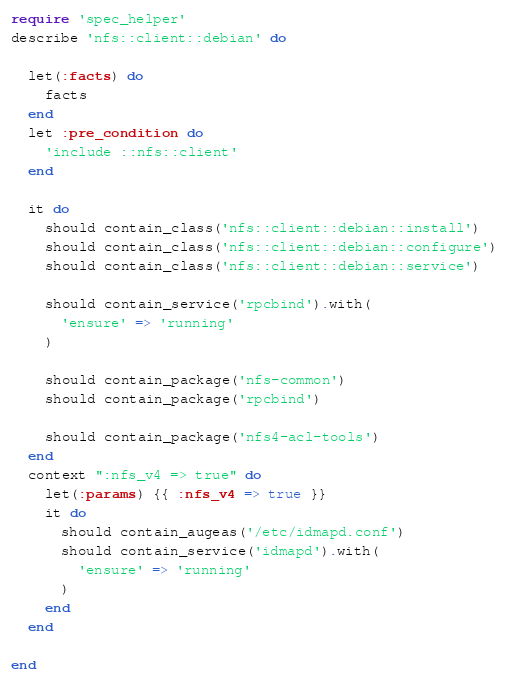<code> <loc_0><loc_0><loc_500><loc_500><_Ruby_>require 'spec_helper'
describe 'nfs::client::debian' do

  let(:facts) do
    facts
  end
  let :pre_condition do 
    'include ::nfs::client'
  end

  it do
    should contain_class('nfs::client::debian::install')
    should contain_class('nfs::client::debian::configure')
    should contain_class('nfs::client::debian::service')

    should contain_service('rpcbind').with(
      'ensure' => 'running'
    )

    should contain_package('nfs-common')
    should contain_package('rpcbind')
    
    should contain_package('nfs4-acl-tools')
  end
  context ":nfs_v4 => true" do
    let(:params) {{ :nfs_v4 => true }}
    it do
      should contain_augeas('/etc/idmapd.conf') 
      should contain_service('idmapd').with(
        'ensure' => 'running'
      )
    end
  end

end
</code> 